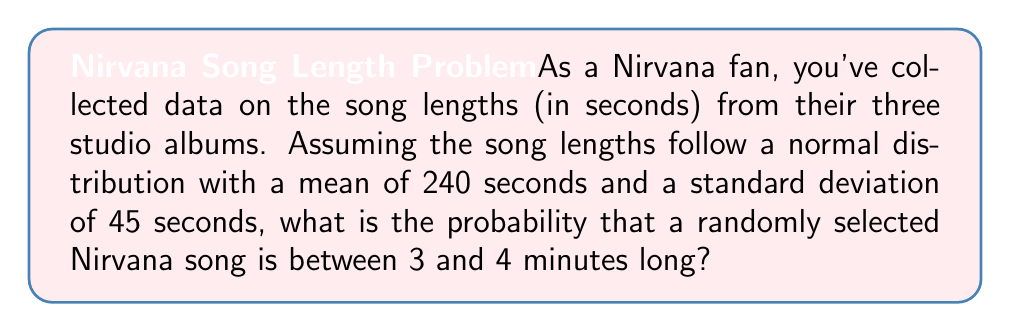What is the answer to this math problem? Let's approach this step-by-step:

1) First, we need to convert the time range from minutes to seconds:
   3 minutes = 180 seconds
   4 minutes = 240 seconds

2) We're given that the song lengths follow a normal distribution with:
   $\mu = 240$ seconds (mean)
   $\sigma = 45$ seconds (standard deviation)

3) To find the probability, we need to calculate the z-scores for both bounds:

   For 180 seconds: $z_1 = \frac{180 - 240}{45} = -\frac{60}{45} = -1.33$
   For 240 seconds: $z_2 = \frac{240 - 240}{45} = 0$

4) Now, we need to find the area under the standard normal curve between these two z-scores. This can be done using the standard normal cumulative distribution function (CDF), often denoted as $\Phi(z)$.

5) The probability is:
   $P(180 < X < 240) = \Phi(0) - \Phi(-1.33)$

6) Using a standard normal table or calculator:
   $\Phi(0) = 0.5$
   $\Phi(-1.33) \approx 0.0918$

7) Therefore, the probability is:
   $0.5 - 0.0918 = 0.4082$
Answer: $0.4082$ or $40.82\%$ 